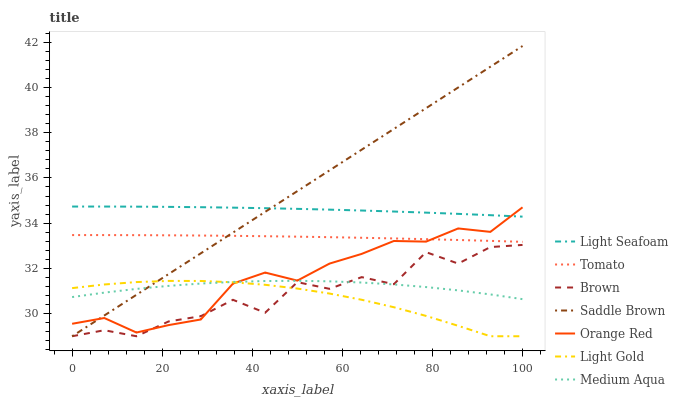Does Light Gold have the minimum area under the curve?
Answer yes or no. Yes. Does Saddle Brown have the maximum area under the curve?
Answer yes or no. Yes. Does Brown have the minimum area under the curve?
Answer yes or no. No. Does Brown have the maximum area under the curve?
Answer yes or no. No. Is Saddle Brown the smoothest?
Answer yes or no. Yes. Is Brown the roughest?
Answer yes or no. Yes. Is Orange Red the smoothest?
Answer yes or no. No. Is Orange Red the roughest?
Answer yes or no. No. Does Brown have the lowest value?
Answer yes or no. Yes. Does Orange Red have the lowest value?
Answer yes or no. No. Does Saddle Brown have the highest value?
Answer yes or no. Yes. Does Brown have the highest value?
Answer yes or no. No. Is Light Gold less than Tomato?
Answer yes or no. Yes. Is Tomato greater than Medium Aqua?
Answer yes or no. Yes. Does Saddle Brown intersect Light Seafoam?
Answer yes or no. Yes. Is Saddle Brown less than Light Seafoam?
Answer yes or no. No. Is Saddle Brown greater than Light Seafoam?
Answer yes or no. No. Does Light Gold intersect Tomato?
Answer yes or no. No. 